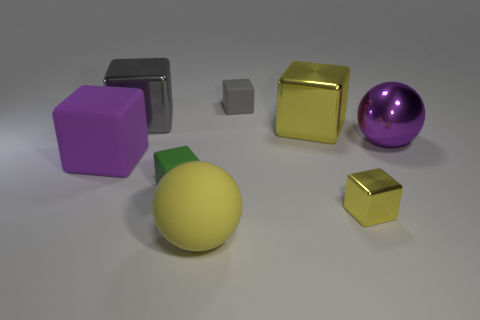Subtract all tiny green matte blocks. How many blocks are left? 5 Subtract 1 cubes. How many cubes are left? 5 Subtract all yellow blocks. How many blocks are left? 4 Subtract all red blocks. Subtract all cyan balls. How many blocks are left? 6 Add 2 big blue blocks. How many objects exist? 10 Subtract all balls. How many objects are left? 6 Subtract 0 green cylinders. How many objects are left? 8 Subtract all small gray cubes. Subtract all tiny green rubber blocks. How many objects are left? 6 Add 7 large gray shiny blocks. How many large gray shiny blocks are left? 8 Add 5 green matte cubes. How many green matte cubes exist? 6 